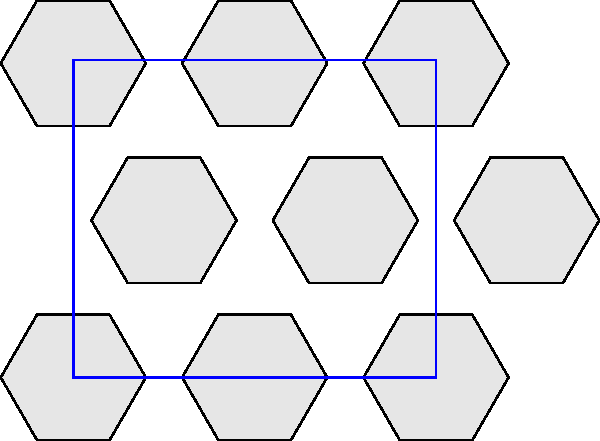You're designing a product showcase page for your e-commerce website. To maximize efficiency, you want to arrange hexagonal product tiles on a rectangular grid. Given a grid of width 4 units and height 3.5 units, what's the maximum number of complete hexagonal tiles (side length 1 unit) that can fit without overlapping or extending beyond the grid? Let's approach this step-by-step:

1) First, we need to understand the dimensions of a hexagon with side length 1:
   - Width: $2$ units
   - Height: $\sqrt{3}$ units

2) In a tightly packed arrangement, hexagons in adjacent rows are offset by half a width. This creates a tessellation pattern.

3) For the width:
   - The grid is 4 units wide
   - Each hexagon is 2 units wide
   - So we can fit 2 full columns of hexagons ($4 \div 2 = 2$)

4) For the height:
   - The grid is 3.5 units high
   - Each hexagon is $\sqrt{3} \approx 1.732$ units high
   - In a tessellation, every two rows of hexagons occupy a height of $3 \times (\sqrt{3} \div 2) \approx 2.598$ units
   - We can fit 2 full rows of hexagons, as $2.598 < 3.5 < 2.598 \times 2$

5) In a tessellated hexagon arrangement:
   - Odd rows have 2 hexagons (matching the number of full columns)
   - Even rows have 3 hexagons (due to the offset)

6) We have 2 rows:
   - First row: 3 hexagons
   - Second row: 2 hexagons

7) Total number of hexagons: $3 + 2 = 5$

Therefore, the maximum number of complete hexagonal tiles that can fit in the given grid is 5.
Answer: 5 hexagonal tiles 